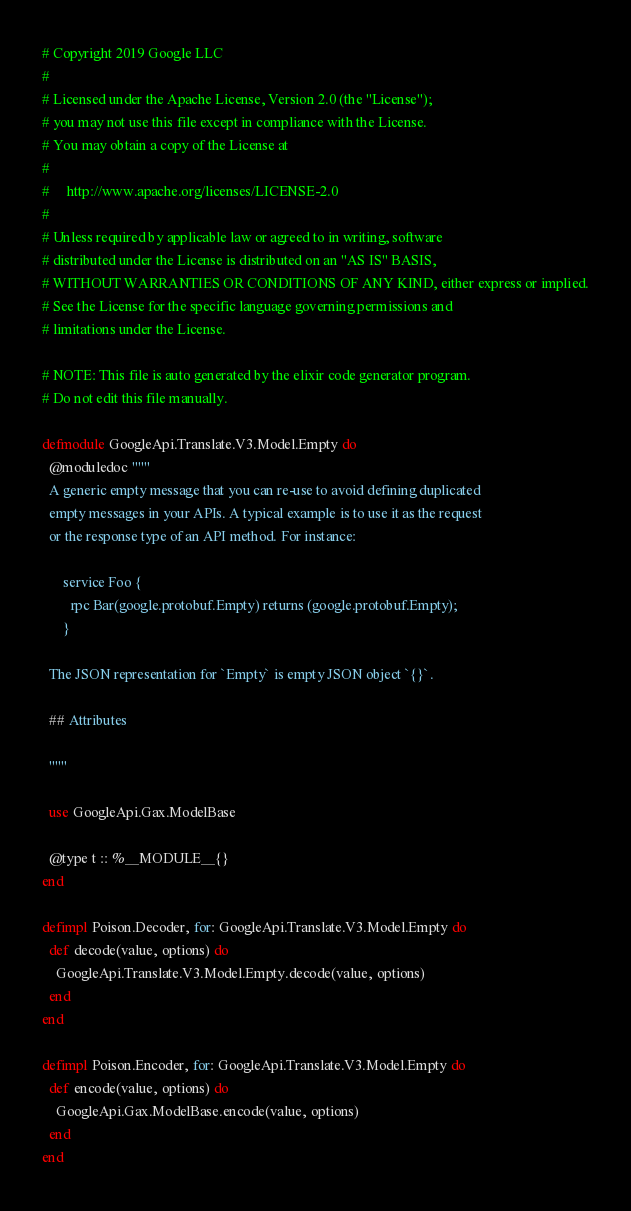<code> <loc_0><loc_0><loc_500><loc_500><_Elixir_># Copyright 2019 Google LLC
#
# Licensed under the Apache License, Version 2.0 (the "License");
# you may not use this file except in compliance with the License.
# You may obtain a copy of the License at
#
#     http://www.apache.org/licenses/LICENSE-2.0
#
# Unless required by applicable law or agreed to in writing, software
# distributed under the License is distributed on an "AS IS" BASIS,
# WITHOUT WARRANTIES OR CONDITIONS OF ANY KIND, either express or implied.
# See the License for the specific language governing permissions and
# limitations under the License.

# NOTE: This file is auto generated by the elixir code generator program.
# Do not edit this file manually.

defmodule GoogleApi.Translate.V3.Model.Empty do
  @moduledoc """
  A generic empty message that you can re-use to avoid defining duplicated
  empty messages in your APIs. A typical example is to use it as the request
  or the response type of an API method. For instance:

      service Foo {
        rpc Bar(google.protobuf.Empty) returns (google.protobuf.Empty);
      }

  The JSON representation for `Empty` is empty JSON object `{}`.

  ## Attributes

  """

  use GoogleApi.Gax.ModelBase

  @type t :: %__MODULE__{}
end

defimpl Poison.Decoder, for: GoogleApi.Translate.V3.Model.Empty do
  def decode(value, options) do
    GoogleApi.Translate.V3.Model.Empty.decode(value, options)
  end
end

defimpl Poison.Encoder, for: GoogleApi.Translate.V3.Model.Empty do
  def encode(value, options) do
    GoogleApi.Gax.ModelBase.encode(value, options)
  end
end
</code> 